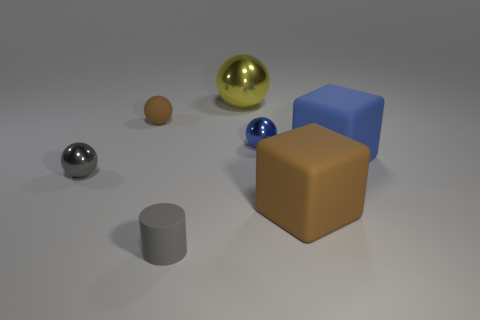Is the size of the gray thing that is on the left side of the brown rubber sphere the same as the yellow metallic thing behind the large brown object?
Your answer should be very brief. No. How many things are small cylinders or brown things?
Keep it short and to the point. 3. There is a large ball on the right side of the tiny rubber thing that is behind the tiny blue metal thing; what is its material?
Ensure brevity in your answer.  Metal. How many other small objects are the same shape as the gray rubber object?
Ensure brevity in your answer.  0. Are there any big rubber cubes that have the same color as the small matte sphere?
Give a very brief answer. Yes. What number of objects are gray matte cylinders left of the big brown object or matte things in front of the small blue sphere?
Your answer should be compact. 3. Is there a tiny rubber cylinder that is behind the large shiny sphere on the right side of the tiny cylinder?
Your answer should be compact. No. There is a blue metal object that is the same size as the brown ball; what shape is it?
Your response must be concise. Sphere. How many things are either objects on the right side of the tiny brown thing or big cubes?
Your answer should be compact. 5. What number of other objects are the same material as the gray ball?
Give a very brief answer. 2. 